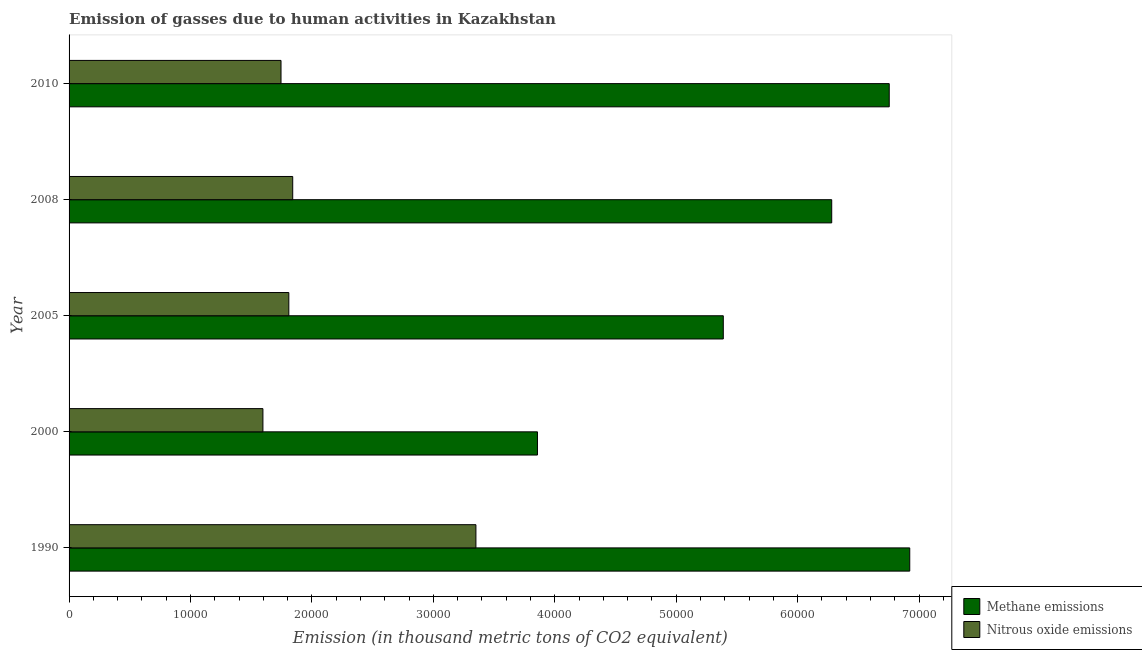How many groups of bars are there?
Keep it short and to the point. 5. Are the number of bars per tick equal to the number of legend labels?
Provide a succinct answer. Yes. How many bars are there on the 2nd tick from the top?
Your answer should be compact. 2. How many bars are there on the 3rd tick from the bottom?
Ensure brevity in your answer.  2. What is the amount of methane emissions in 2010?
Give a very brief answer. 6.75e+04. Across all years, what is the maximum amount of nitrous oxide emissions?
Your answer should be compact. 3.35e+04. Across all years, what is the minimum amount of methane emissions?
Provide a short and direct response. 3.86e+04. What is the total amount of nitrous oxide emissions in the graph?
Give a very brief answer. 1.03e+05. What is the difference between the amount of nitrous oxide emissions in 2000 and that in 2010?
Make the answer very short. -1489.6. What is the difference between the amount of nitrous oxide emissions in 2010 and the amount of methane emissions in 1990?
Offer a terse response. -5.18e+04. What is the average amount of nitrous oxide emissions per year?
Keep it short and to the point. 2.07e+04. In the year 2005, what is the difference between the amount of methane emissions and amount of nitrous oxide emissions?
Offer a very short reply. 3.58e+04. In how many years, is the amount of nitrous oxide emissions greater than 18000 thousand metric tons?
Offer a terse response. 3. What is the ratio of the amount of nitrous oxide emissions in 2005 to that in 2010?
Offer a terse response. 1.04. Is the difference between the amount of nitrous oxide emissions in 2000 and 2005 greater than the difference between the amount of methane emissions in 2000 and 2005?
Provide a short and direct response. Yes. What is the difference between the highest and the second highest amount of methane emissions?
Offer a very short reply. 1690.4. What is the difference between the highest and the lowest amount of methane emissions?
Ensure brevity in your answer.  3.07e+04. In how many years, is the amount of methane emissions greater than the average amount of methane emissions taken over all years?
Provide a short and direct response. 3. Is the sum of the amount of nitrous oxide emissions in 1990 and 2005 greater than the maximum amount of methane emissions across all years?
Provide a short and direct response. No. What does the 2nd bar from the top in 2010 represents?
Your response must be concise. Methane emissions. What does the 1st bar from the bottom in 2000 represents?
Give a very brief answer. Methane emissions. How many bars are there?
Keep it short and to the point. 10. What is the difference between two consecutive major ticks on the X-axis?
Ensure brevity in your answer.  10000. Where does the legend appear in the graph?
Make the answer very short. Bottom right. How are the legend labels stacked?
Offer a terse response. Vertical. What is the title of the graph?
Offer a very short reply. Emission of gasses due to human activities in Kazakhstan. Does "Under-five" appear as one of the legend labels in the graph?
Your response must be concise. No. What is the label or title of the X-axis?
Your answer should be compact. Emission (in thousand metric tons of CO2 equivalent). What is the Emission (in thousand metric tons of CO2 equivalent) of Methane emissions in 1990?
Offer a terse response. 6.92e+04. What is the Emission (in thousand metric tons of CO2 equivalent) of Nitrous oxide emissions in 1990?
Give a very brief answer. 3.35e+04. What is the Emission (in thousand metric tons of CO2 equivalent) in Methane emissions in 2000?
Keep it short and to the point. 3.86e+04. What is the Emission (in thousand metric tons of CO2 equivalent) of Nitrous oxide emissions in 2000?
Give a very brief answer. 1.60e+04. What is the Emission (in thousand metric tons of CO2 equivalent) in Methane emissions in 2005?
Offer a very short reply. 5.39e+04. What is the Emission (in thousand metric tons of CO2 equivalent) in Nitrous oxide emissions in 2005?
Provide a short and direct response. 1.81e+04. What is the Emission (in thousand metric tons of CO2 equivalent) in Methane emissions in 2008?
Ensure brevity in your answer.  6.28e+04. What is the Emission (in thousand metric tons of CO2 equivalent) of Nitrous oxide emissions in 2008?
Ensure brevity in your answer.  1.84e+04. What is the Emission (in thousand metric tons of CO2 equivalent) in Methane emissions in 2010?
Ensure brevity in your answer.  6.75e+04. What is the Emission (in thousand metric tons of CO2 equivalent) in Nitrous oxide emissions in 2010?
Ensure brevity in your answer.  1.75e+04. Across all years, what is the maximum Emission (in thousand metric tons of CO2 equivalent) of Methane emissions?
Ensure brevity in your answer.  6.92e+04. Across all years, what is the maximum Emission (in thousand metric tons of CO2 equivalent) of Nitrous oxide emissions?
Make the answer very short. 3.35e+04. Across all years, what is the minimum Emission (in thousand metric tons of CO2 equivalent) of Methane emissions?
Ensure brevity in your answer.  3.86e+04. Across all years, what is the minimum Emission (in thousand metric tons of CO2 equivalent) of Nitrous oxide emissions?
Give a very brief answer. 1.60e+04. What is the total Emission (in thousand metric tons of CO2 equivalent) in Methane emissions in the graph?
Ensure brevity in your answer.  2.92e+05. What is the total Emission (in thousand metric tons of CO2 equivalent) of Nitrous oxide emissions in the graph?
Your response must be concise. 1.03e+05. What is the difference between the Emission (in thousand metric tons of CO2 equivalent) in Methane emissions in 1990 and that in 2000?
Your answer should be very brief. 3.07e+04. What is the difference between the Emission (in thousand metric tons of CO2 equivalent) of Nitrous oxide emissions in 1990 and that in 2000?
Offer a very short reply. 1.75e+04. What is the difference between the Emission (in thousand metric tons of CO2 equivalent) in Methane emissions in 1990 and that in 2005?
Provide a succinct answer. 1.54e+04. What is the difference between the Emission (in thousand metric tons of CO2 equivalent) in Nitrous oxide emissions in 1990 and that in 2005?
Offer a very short reply. 1.54e+04. What is the difference between the Emission (in thousand metric tons of CO2 equivalent) in Methane emissions in 1990 and that in 2008?
Give a very brief answer. 6426.2. What is the difference between the Emission (in thousand metric tons of CO2 equivalent) of Nitrous oxide emissions in 1990 and that in 2008?
Offer a very short reply. 1.51e+04. What is the difference between the Emission (in thousand metric tons of CO2 equivalent) of Methane emissions in 1990 and that in 2010?
Make the answer very short. 1690.4. What is the difference between the Emission (in thousand metric tons of CO2 equivalent) in Nitrous oxide emissions in 1990 and that in 2010?
Make the answer very short. 1.61e+04. What is the difference between the Emission (in thousand metric tons of CO2 equivalent) of Methane emissions in 2000 and that in 2005?
Provide a succinct answer. -1.53e+04. What is the difference between the Emission (in thousand metric tons of CO2 equivalent) of Nitrous oxide emissions in 2000 and that in 2005?
Your answer should be compact. -2133.3. What is the difference between the Emission (in thousand metric tons of CO2 equivalent) of Methane emissions in 2000 and that in 2008?
Your answer should be very brief. -2.42e+04. What is the difference between the Emission (in thousand metric tons of CO2 equivalent) of Nitrous oxide emissions in 2000 and that in 2008?
Your response must be concise. -2454. What is the difference between the Emission (in thousand metric tons of CO2 equivalent) of Methane emissions in 2000 and that in 2010?
Your response must be concise. -2.90e+04. What is the difference between the Emission (in thousand metric tons of CO2 equivalent) of Nitrous oxide emissions in 2000 and that in 2010?
Ensure brevity in your answer.  -1489.6. What is the difference between the Emission (in thousand metric tons of CO2 equivalent) of Methane emissions in 2005 and that in 2008?
Provide a short and direct response. -8929.6. What is the difference between the Emission (in thousand metric tons of CO2 equivalent) of Nitrous oxide emissions in 2005 and that in 2008?
Offer a terse response. -320.7. What is the difference between the Emission (in thousand metric tons of CO2 equivalent) in Methane emissions in 2005 and that in 2010?
Your response must be concise. -1.37e+04. What is the difference between the Emission (in thousand metric tons of CO2 equivalent) in Nitrous oxide emissions in 2005 and that in 2010?
Ensure brevity in your answer.  643.7. What is the difference between the Emission (in thousand metric tons of CO2 equivalent) in Methane emissions in 2008 and that in 2010?
Your answer should be very brief. -4735.8. What is the difference between the Emission (in thousand metric tons of CO2 equivalent) of Nitrous oxide emissions in 2008 and that in 2010?
Your response must be concise. 964.4. What is the difference between the Emission (in thousand metric tons of CO2 equivalent) of Methane emissions in 1990 and the Emission (in thousand metric tons of CO2 equivalent) of Nitrous oxide emissions in 2000?
Provide a succinct answer. 5.33e+04. What is the difference between the Emission (in thousand metric tons of CO2 equivalent) in Methane emissions in 1990 and the Emission (in thousand metric tons of CO2 equivalent) in Nitrous oxide emissions in 2005?
Make the answer very short. 5.11e+04. What is the difference between the Emission (in thousand metric tons of CO2 equivalent) in Methane emissions in 1990 and the Emission (in thousand metric tons of CO2 equivalent) in Nitrous oxide emissions in 2008?
Provide a succinct answer. 5.08e+04. What is the difference between the Emission (in thousand metric tons of CO2 equivalent) in Methane emissions in 1990 and the Emission (in thousand metric tons of CO2 equivalent) in Nitrous oxide emissions in 2010?
Offer a very short reply. 5.18e+04. What is the difference between the Emission (in thousand metric tons of CO2 equivalent) of Methane emissions in 2000 and the Emission (in thousand metric tons of CO2 equivalent) of Nitrous oxide emissions in 2005?
Your answer should be very brief. 2.05e+04. What is the difference between the Emission (in thousand metric tons of CO2 equivalent) of Methane emissions in 2000 and the Emission (in thousand metric tons of CO2 equivalent) of Nitrous oxide emissions in 2008?
Offer a very short reply. 2.02e+04. What is the difference between the Emission (in thousand metric tons of CO2 equivalent) of Methane emissions in 2000 and the Emission (in thousand metric tons of CO2 equivalent) of Nitrous oxide emissions in 2010?
Your answer should be compact. 2.11e+04. What is the difference between the Emission (in thousand metric tons of CO2 equivalent) of Methane emissions in 2005 and the Emission (in thousand metric tons of CO2 equivalent) of Nitrous oxide emissions in 2008?
Provide a short and direct response. 3.55e+04. What is the difference between the Emission (in thousand metric tons of CO2 equivalent) in Methane emissions in 2005 and the Emission (in thousand metric tons of CO2 equivalent) in Nitrous oxide emissions in 2010?
Offer a terse response. 3.64e+04. What is the difference between the Emission (in thousand metric tons of CO2 equivalent) in Methane emissions in 2008 and the Emission (in thousand metric tons of CO2 equivalent) in Nitrous oxide emissions in 2010?
Give a very brief answer. 4.54e+04. What is the average Emission (in thousand metric tons of CO2 equivalent) in Methane emissions per year?
Your response must be concise. 5.84e+04. What is the average Emission (in thousand metric tons of CO2 equivalent) of Nitrous oxide emissions per year?
Your answer should be very brief. 2.07e+04. In the year 1990, what is the difference between the Emission (in thousand metric tons of CO2 equivalent) in Methane emissions and Emission (in thousand metric tons of CO2 equivalent) in Nitrous oxide emissions?
Your answer should be compact. 3.57e+04. In the year 2000, what is the difference between the Emission (in thousand metric tons of CO2 equivalent) of Methane emissions and Emission (in thousand metric tons of CO2 equivalent) of Nitrous oxide emissions?
Your response must be concise. 2.26e+04. In the year 2005, what is the difference between the Emission (in thousand metric tons of CO2 equivalent) of Methane emissions and Emission (in thousand metric tons of CO2 equivalent) of Nitrous oxide emissions?
Your answer should be very brief. 3.58e+04. In the year 2008, what is the difference between the Emission (in thousand metric tons of CO2 equivalent) in Methane emissions and Emission (in thousand metric tons of CO2 equivalent) in Nitrous oxide emissions?
Ensure brevity in your answer.  4.44e+04. In the year 2010, what is the difference between the Emission (in thousand metric tons of CO2 equivalent) in Methane emissions and Emission (in thousand metric tons of CO2 equivalent) in Nitrous oxide emissions?
Give a very brief answer. 5.01e+04. What is the ratio of the Emission (in thousand metric tons of CO2 equivalent) of Methane emissions in 1990 to that in 2000?
Provide a succinct answer. 1.79. What is the ratio of the Emission (in thousand metric tons of CO2 equivalent) in Nitrous oxide emissions in 1990 to that in 2000?
Offer a terse response. 2.1. What is the ratio of the Emission (in thousand metric tons of CO2 equivalent) of Methane emissions in 1990 to that in 2005?
Keep it short and to the point. 1.28. What is the ratio of the Emission (in thousand metric tons of CO2 equivalent) of Nitrous oxide emissions in 1990 to that in 2005?
Your answer should be compact. 1.85. What is the ratio of the Emission (in thousand metric tons of CO2 equivalent) of Methane emissions in 1990 to that in 2008?
Offer a terse response. 1.1. What is the ratio of the Emission (in thousand metric tons of CO2 equivalent) in Nitrous oxide emissions in 1990 to that in 2008?
Your answer should be compact. 1.82. What is the ratio of the Emission (in thousand metric tons of CO2 equivalent) in Methane emissions in 1990 to that in 2010?
Make the answer very short. 1.02. What is the ratio of the Emission (in thousand metric tons of CO2 equivalent) in Nitrous oxide emissions in 1990 to that in 2010?
Your answer should be very brief. 1.92. What is the ratio of the Emission (in thousand metric tons of CO2 equivalent) in Methane emissions in 2000 to that in 2005?
Offer a very short reply. 0.72. What is the ratio of the Emission (in thousand metric tons of CO2 equivalent) in Nitrous oxide emissions in 2000 to that in 2005?
Provide a short and direct response. 0.88. What is the ratio of the Emission (in thousand metric tons of CO2 equivalent) of Methane emissions in 2000 to that in 2008?
Ensure brevity in your answer.  0.61. What is the ratio of the Emission (in thousand metric tons of CO2 equivalent) of Nitrous oxide emissions in 2000 to that in 2008?
Make the answer very short. 0.87. What is the ratio of the Emission (in thousand metric tons of CO2 equivalent) of Methane emissions in 2000 to that in 2010?
Offer a very short reply. 0.57. What is the ratio of the Emission (in thousand metric tons of CO2 equivalent) of Nitrous oxide emissions in 2000 to that in 2010?
Ensure brevity in your answer.  0.91. What is the ratio of the Emission (in thousand metric tons of CO2 equivalent) of Methane emissions in 2005 to that in 2008?
Keep it short and to the point. 0.86. What is the ratio of the Emission (in thousand metric tons of CO2 equivalent) of Nitrous oxide emissions in 2005 to that in 2008?
Offer a terse response. 0.98. What is the ratio of the Emission (in thousand metric tons of CO2 equivalent) of Methane emissions in 2005 to that in 2010?
Provide a short and direct response. 0.8. What is the ratio of the Emission (in thousand metric tons of CO2 equivalent) in Nitrous oxide emissions in 2005 to that in 2010?
Ensure brevity in your answer.  1.04. What is the ratio of the Emission (in thousand metric tons of CO2 equivalent) in Methane emissions in 2008 to that in 2010?
Your answer should be very brief. 0.93. What is the ratio of the Emission (in thousand metric tons of CO2 equivalent) in Nitrous oxide emissions in 2008 to that in 2010?
Give a very brief answer. 1.06. What is the difference between the highest and the second highest Emission (in thousand metric tons of CO2 equivalent) in Methane emissions?
Provide a succinct answer. 1690.4. What is the difference between the highest and the second highest Emission (in thousand metric tons of CO2 equivalent) in Nitrous oxide emissions?
Your response must be concise. 1.51e+04. What is the difference between the highest and the lowest Emission (in thousand metric tons of CO2 equivalent) of Methane emissions?
Provide a short and direct response. 3.07e+04. What is the difference between the highest and the lowest Emission (in thousand metric tons of CO2 equivalent) in Nitrous oxide emissions?
Provide a succinct answer. 1.75e+04. 